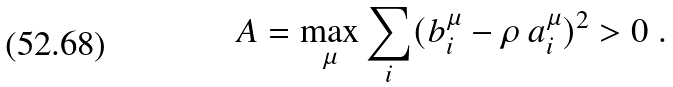Convert formula to latex. <formula><loc_0><loc_0><loc_500><loc_500>A = \max _ { \mu } \sum _ { i } ( b _ { i } ^ { \mu } - \rho \, a _ { i } ^ { \mu } ) ^ { 2 } > 0 \ .</formula> 